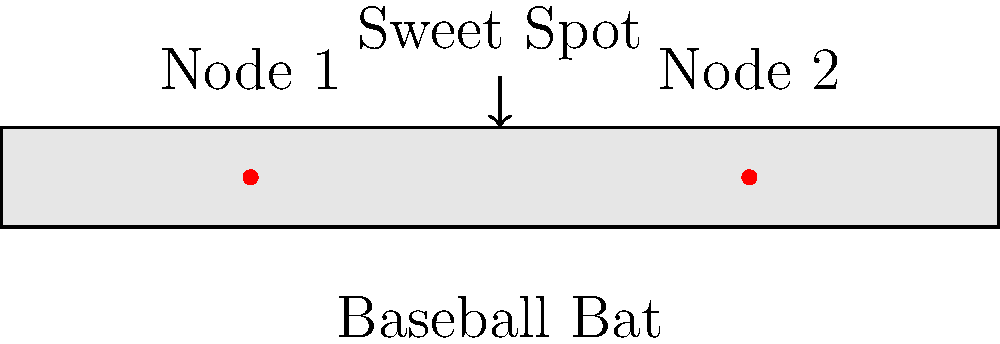Based on the vibration node diagram of a baseball bat shown above, where is the sweet spot located in relation to the two nodes, and why is this location considered optimal for hitting? To determine the sweet spot on a baseball bat using a vibration node diagram, follow these steps:

1. Identify the nodes: In the diagram, we can see two red dots labeled as Node 1 and Node 2. These represent the points of minimum vibration on the bat.

2. Locate the sweet spot: The sweet spot is typically found between the two nodes, usually closer to the end of the bat (Node 2). In this diagram, it's marked halfway between the two nodes.

3. Understand why this location is optimal:
   a) Reduced vibration: The sweet spot experiences the least amount of vibration upon impact, resulting in less energy loss and more power transfer to the ball.
   b) Center of percussion: This location is near the center of percussion, where the impact forces are balanced, reducing the "sting" felt by the batter's hands.
   c) Trampoline effect: The area between the nodes allows for maximum flex of the bat, creating a "trampoline effect" that increases ball speed off the bat.

4. Consider the physics:
   The sweet spot's location can be expressed mathematically as:

   $$x_{sweet} = \frac{x_1 + x_2}{2}$$

   Where $x_1$ and $x_2$ are the distances of Node 1 and Node 2 from the handle end of the bat, respectively.

5. Optimal performance: Hitting the ball at this location results in maximum energy transfer, reduced vibration, and increased comfort for the batter, leading to better overall performance.
Answer: Between the two vibration nodes, closer to the end node; optimal for reduced vibration and maximum energy transfer. 